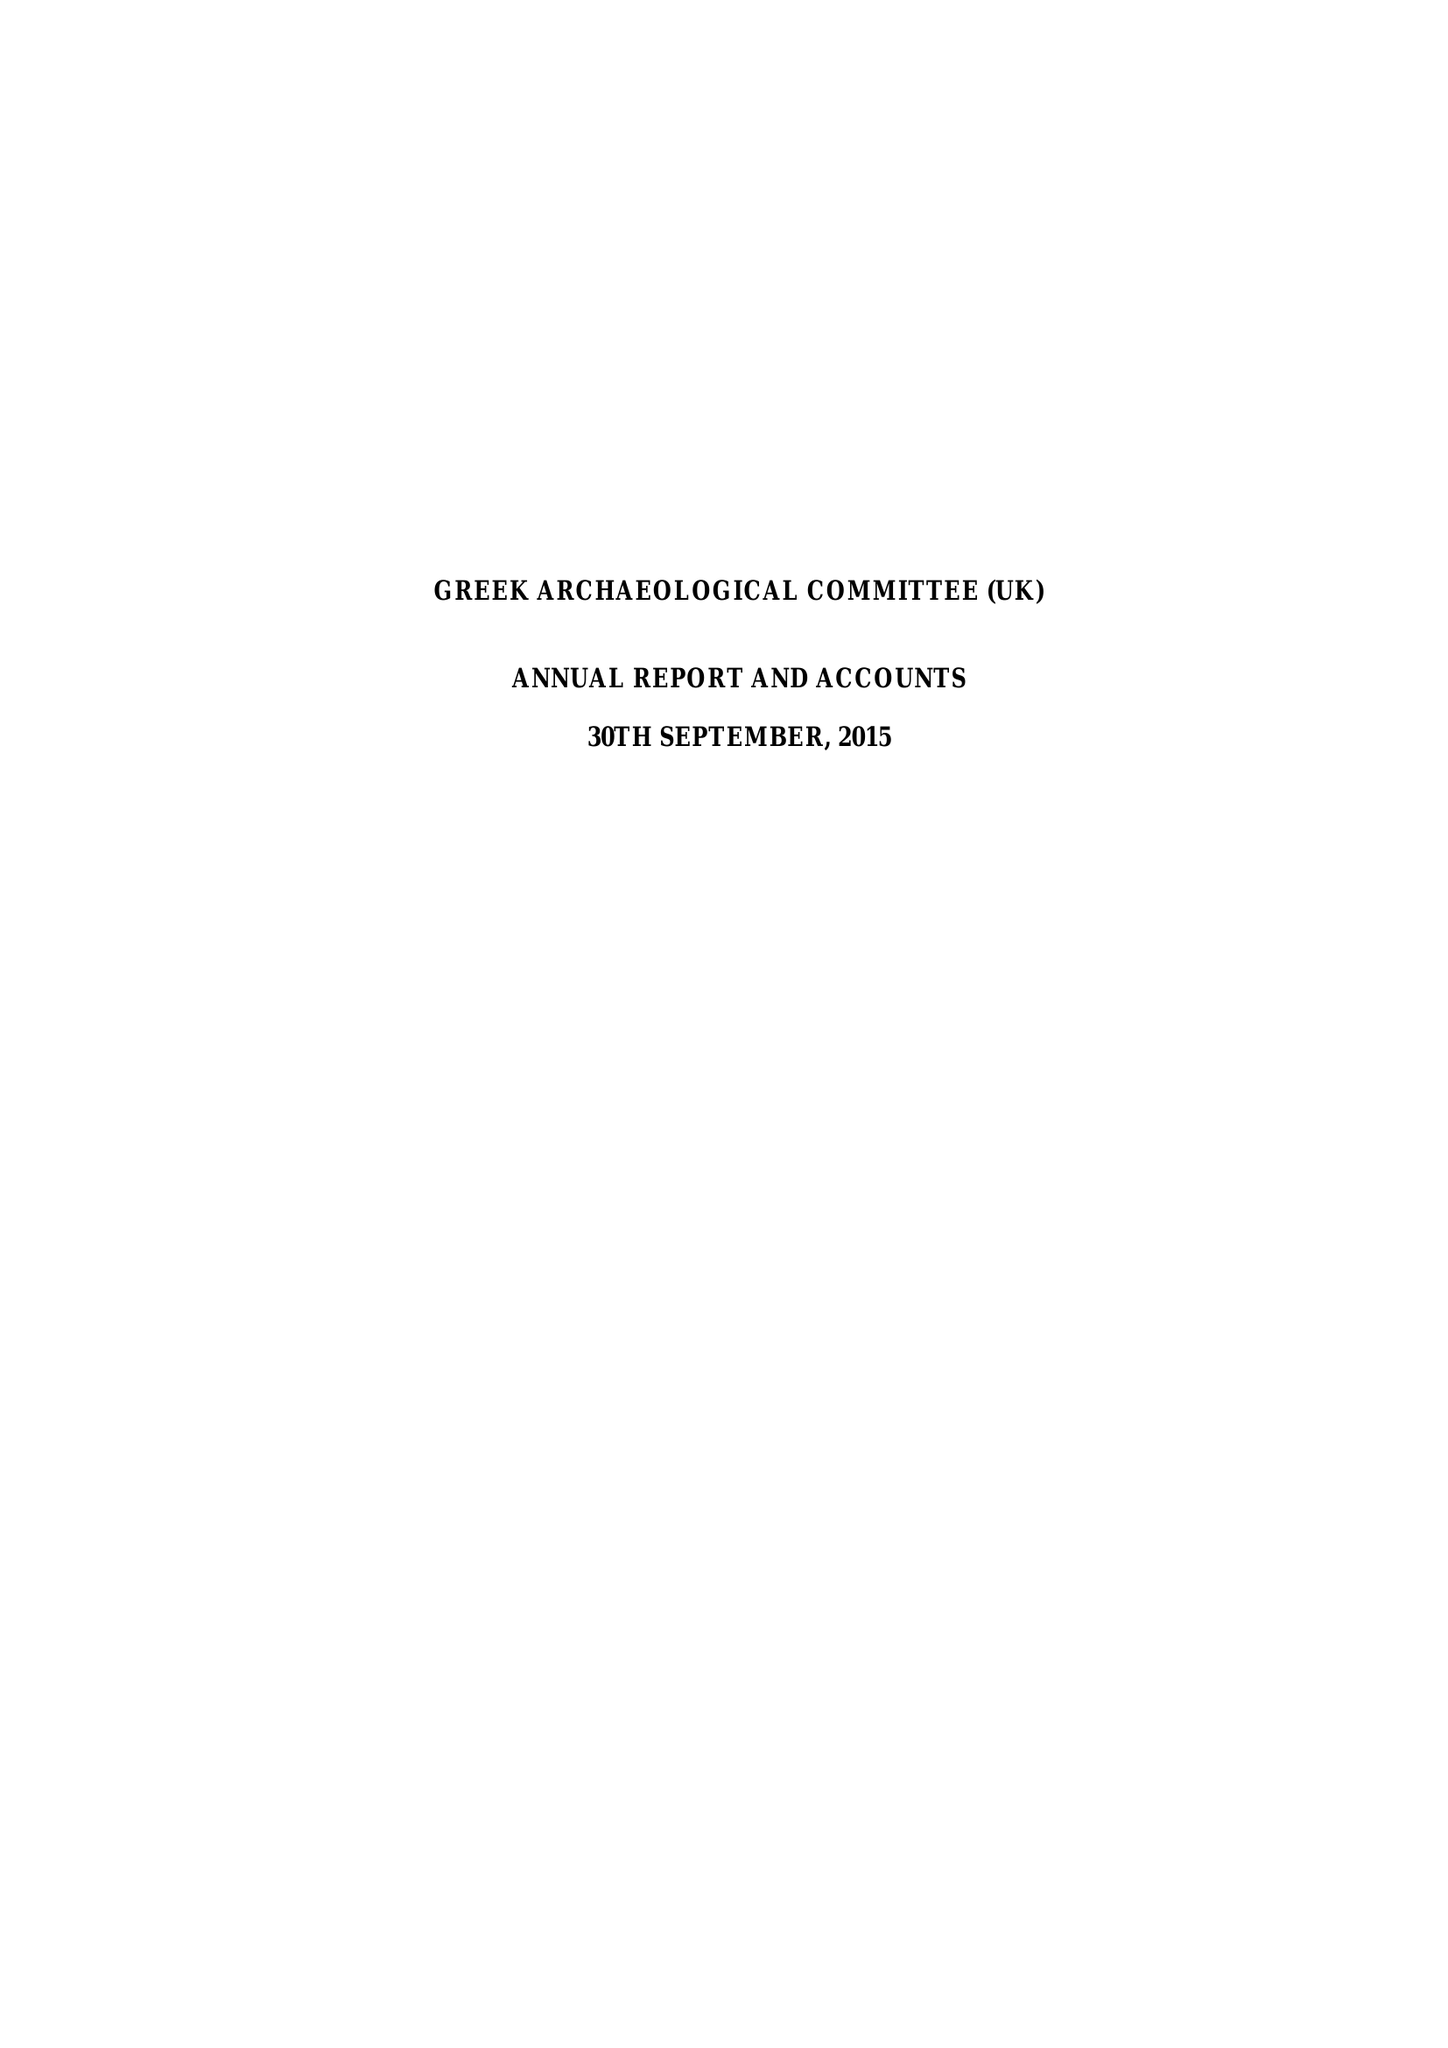What is the value for the address__street_line?
Answer the question using a single word or phrase. 5 RIVERVIEW GARDENS 